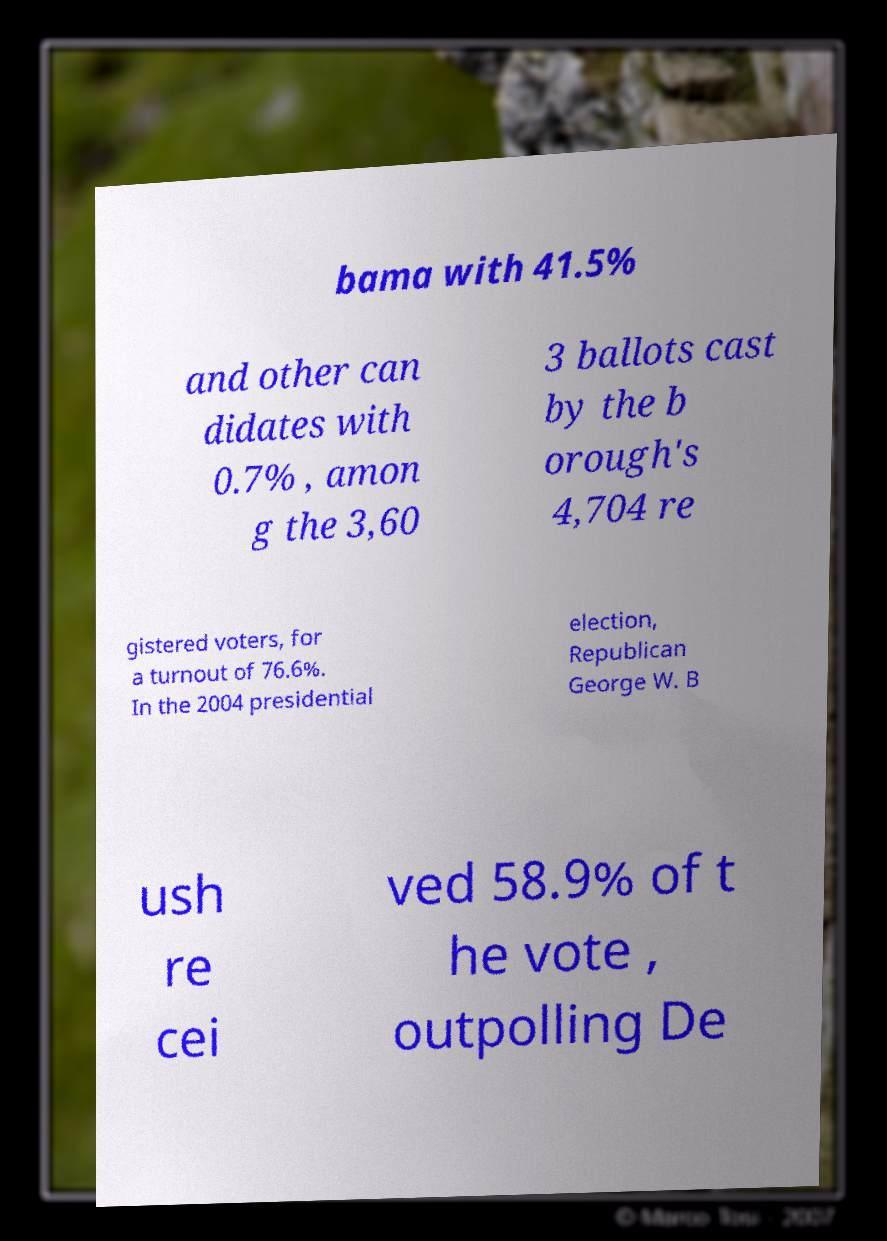Can you read and provide the text displayed in the image?This photo seems to have some interesting text. Can you extract and type it out for me? bama with 41.5% and other can didates with 0.7% , amon g the 3,60 3 ballots cast by the b orough's 4,704 re gistered voters, for a turnout of 76.6%. In the 2004 presidential election, Republican George W. B ush re cei ved 58.9% of t he vote , outpolling De 